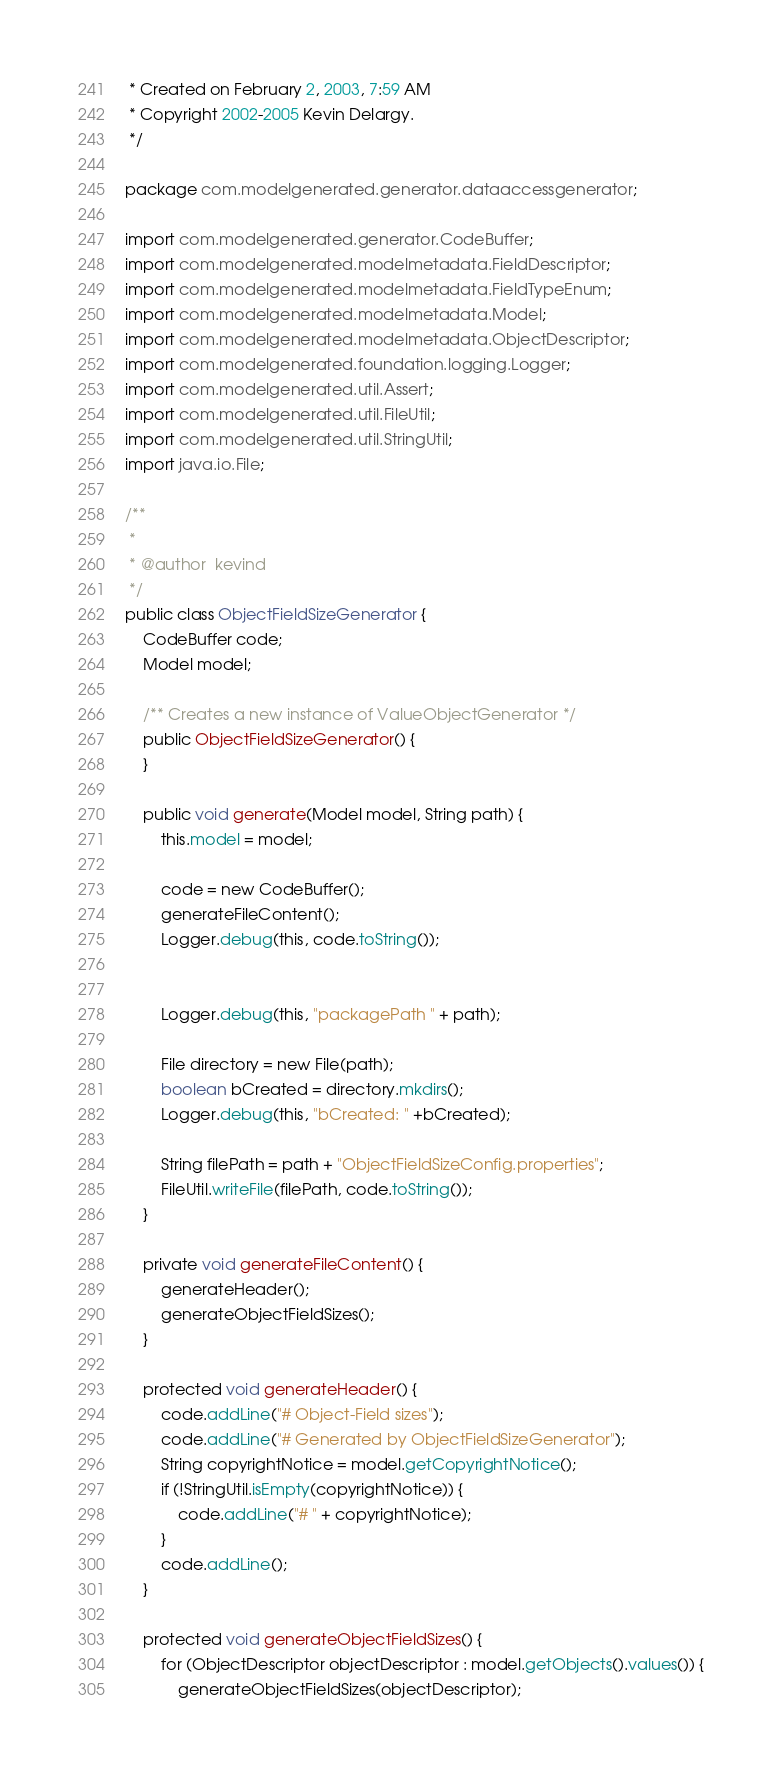<code> <loc_0><loc_0><loc_500><loc_500><_Java_> * Created on February 2, 2003, 7:59 AM
 * Copyright 2002-2005 Kevin Delargy.
 */

package com.modelgenerated.generator.dataaccessgenerator;

import com.modelgenerated.generator.CodeBuffer;
import com.modelgenerated.modelmetadata.FieldDescriptor;
import com.modelgenerated.modelmetadata.FieldTypeEnum;
import com.modelgenerated.modelmetadata.Model;
import com.modelgenerated.modelmetadata.ObjectDescriptor;
import com.modelgenerated.foundation.logging.Logger;
import com.modelgenerated.util.Assert;
import com.modelgenerated.util.FileUtil;
import com.modelgenerated.util.StringUtil;
import java.io.File;

/**
 *
 * @author  kevind
 */
public class ObjectFieldSizeGenerator {
    CodeBuffer code;
    Model model;
    
    /** Creates a new instance of ValueObjectGenerator */
    public ObjectFieldSizeGenerator() {
    }
    
    public void generate(Model model, String path) {
        this.model = model;
        
        code = new CodeBuffer();
        generateFileContent();
        Logger.debug(this, code.toString());        

        
        Logger.debug(this, "packagePath " + path);
                
        File directory = new File(path);
        boolean bCreated = directory.mkdirs();        
        Logger.debug(this, "bCreated: " +bCreated);
        
        String filePath = path + "ObjectFieldSizeConfig.properties";
        FileUtil.writeFile(filePath, code.toString());
    }
    
    private void generateFileContent() {
        generateHeader();
        generateObjectFieldSizes();        
    }
    
    protected void generateHeader() {
        code.addLine("# Object-Field sizes");
        code.addLine("# Generated by ObjectFieldSizeGenerator");
        String copyrightNotice = model.getCopyrightNotice();
        if (!StringUtil.isEmpty(copyrightNotice)) { 
            code.addLine("# " + copyrightNotice);
        }
        code.addLine();
    }
    
    protected void generateObjectFieldSizes() {
        for (ObjectDescriptor objectDescriptor : model.getObjects().values()) {
            generateObjectFieldSizes(objectDescriptor);            </code> 